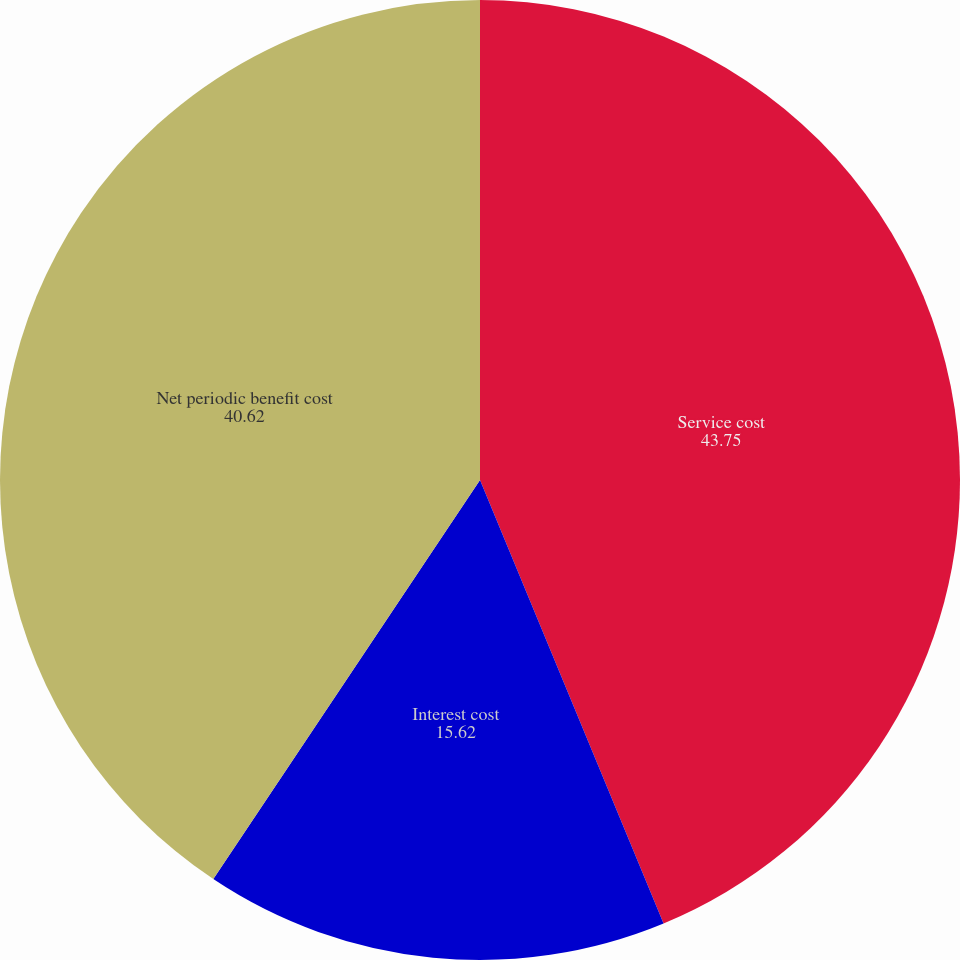<chart> <loc_0><loc_0><loc_500><loc_500><pie_chart><fcel>Service cost<fcel>Interest cost<fcel>Net periodic benefit cost<nl><fcel>43.75%<fcel>15.62%<fcel>40.62%<nl></chart> 